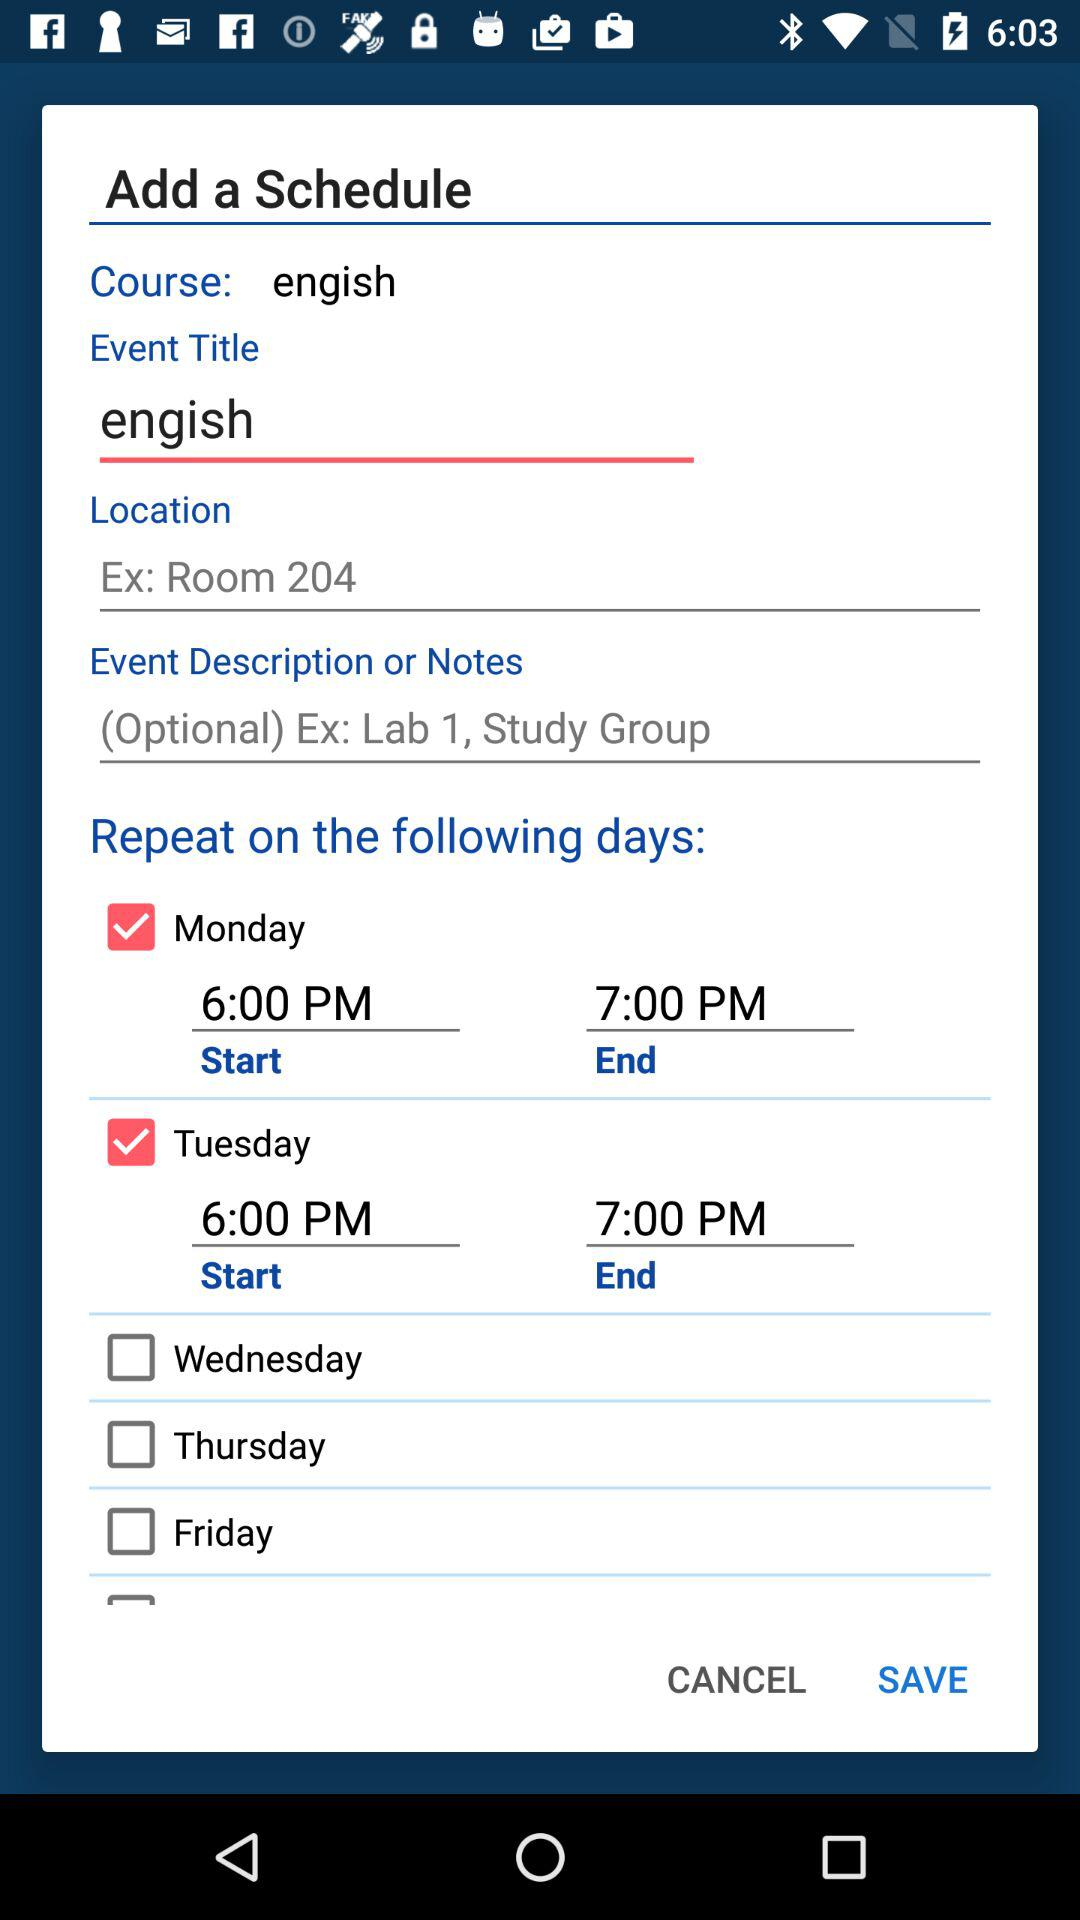What is the start time of the Tuesday schedule? The start time is 6 PM. 